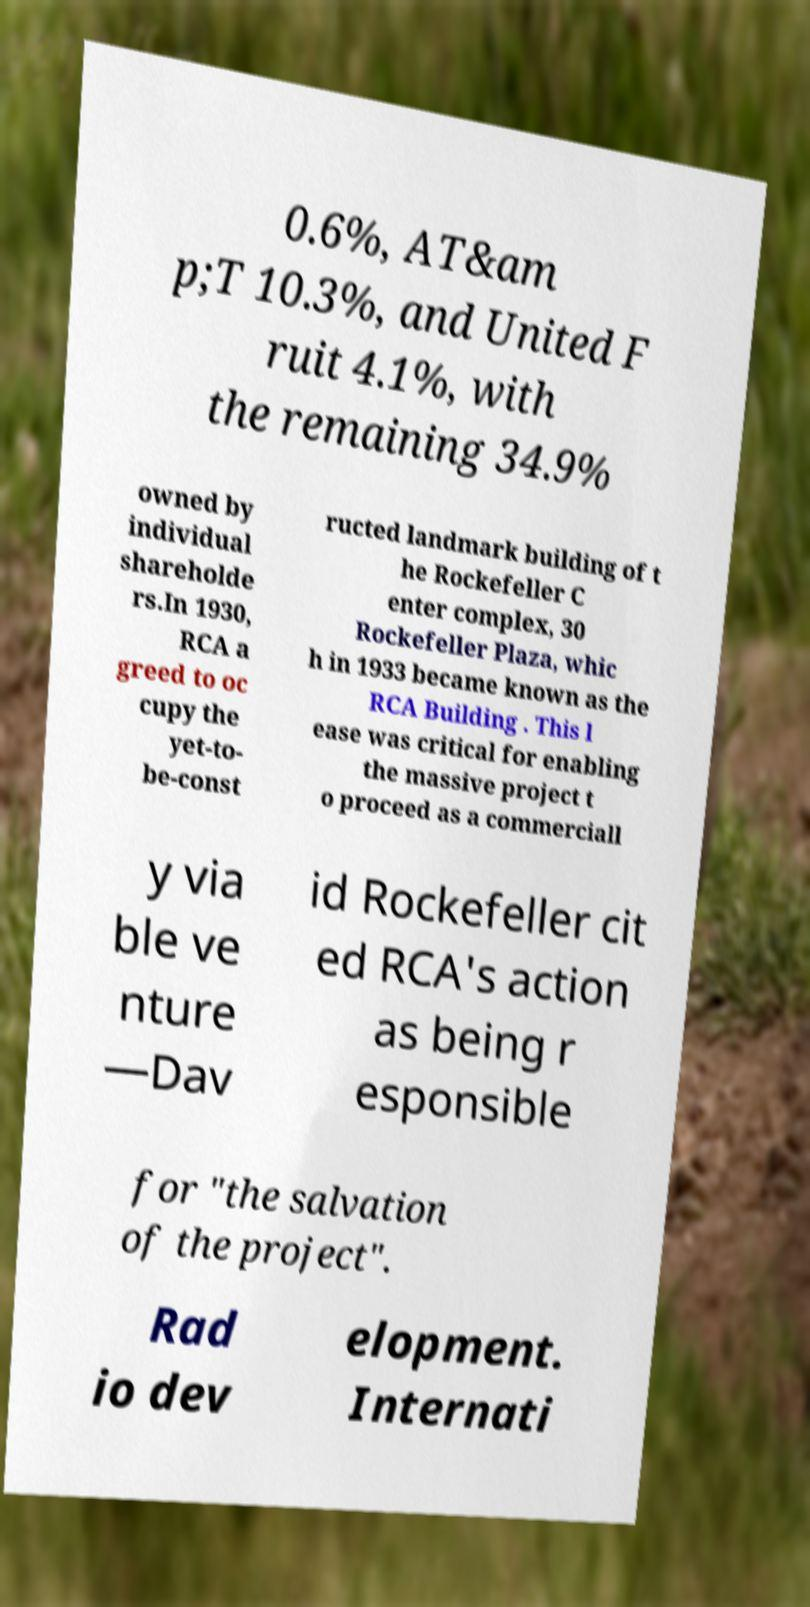Can you accurately transcribe the text from the provided image for me? 0.6%, AT&am p;T 10.3%, and United F ruit 4.1%, with the remaining 34.9% owned by individual shareholde rs.In 1930, RCA a greed to oc cupy the yet-to- be-const ructed landmark building of t he Rockefeller C enter complex, 30 Rockefeller Plaza, whic h in 1933 became known as the RCA Building . This l ease was critical for enabling the massive project t o proceed as a commerciall y via ble ve nture —Dav id Rockefeller cit ed RCA's action as being r esponsible for "the salvation of the project". Rad io dev elopment. Internati 